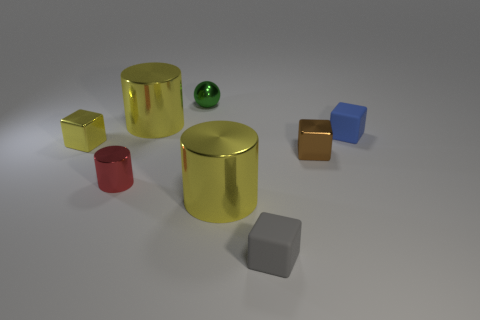Can you enumerate and describe the objects seen in the image? Certainly! In the image, there are seven distinct objects: one small green rubber ball, one large golden metallic cylinder, one medium-sized red metallic cylinder, one yellow metallic cube, one orange metallic cube, one blue cube that appears to have a matte finish, and one gray cube that also has a matte finish. 